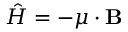Convert formula to latex. <formula><loc_0><loc_0><loc_500><loc_500>{ \hat { H } } = - { \mu } \cdot B</formula> 